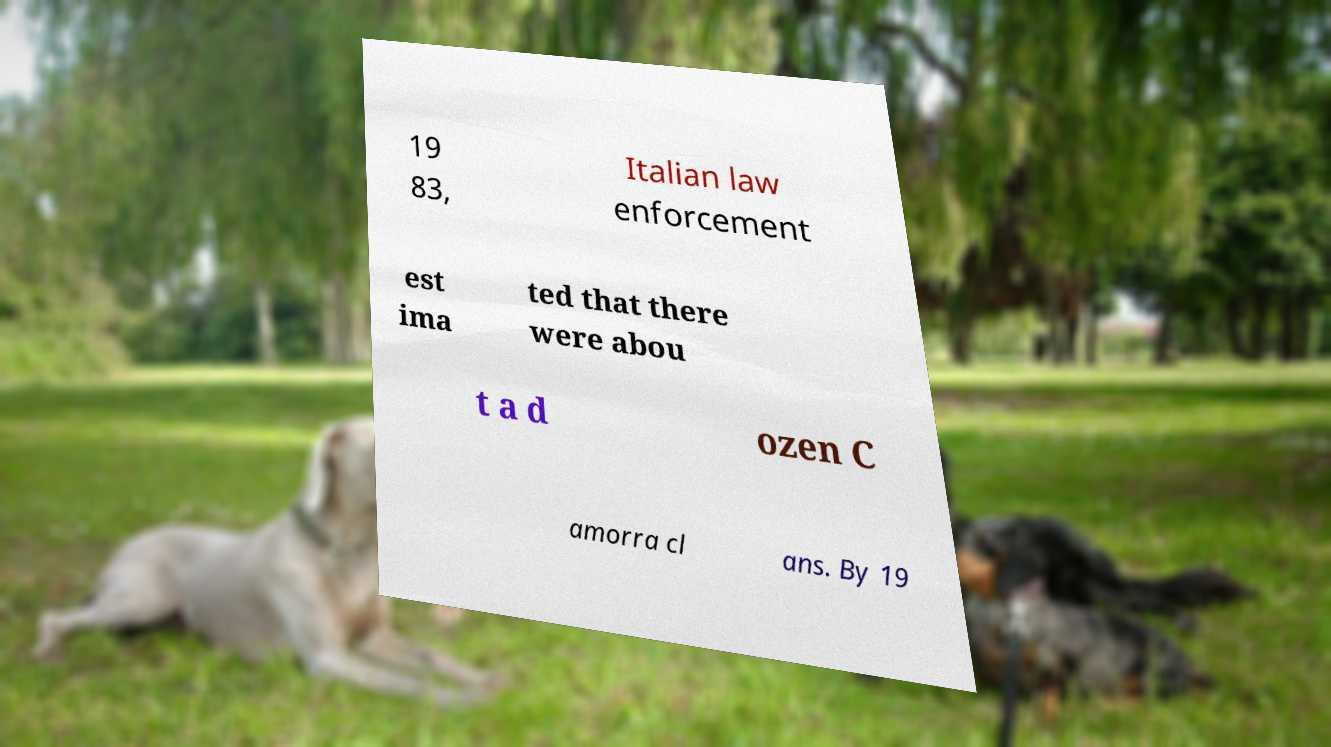For documentation purposes, I need the text within this image transcribed. Could you provide that? 19 83, Italian law enforcement est ima ted that there were abou t a d ozen C amorra cl ans. By 19 